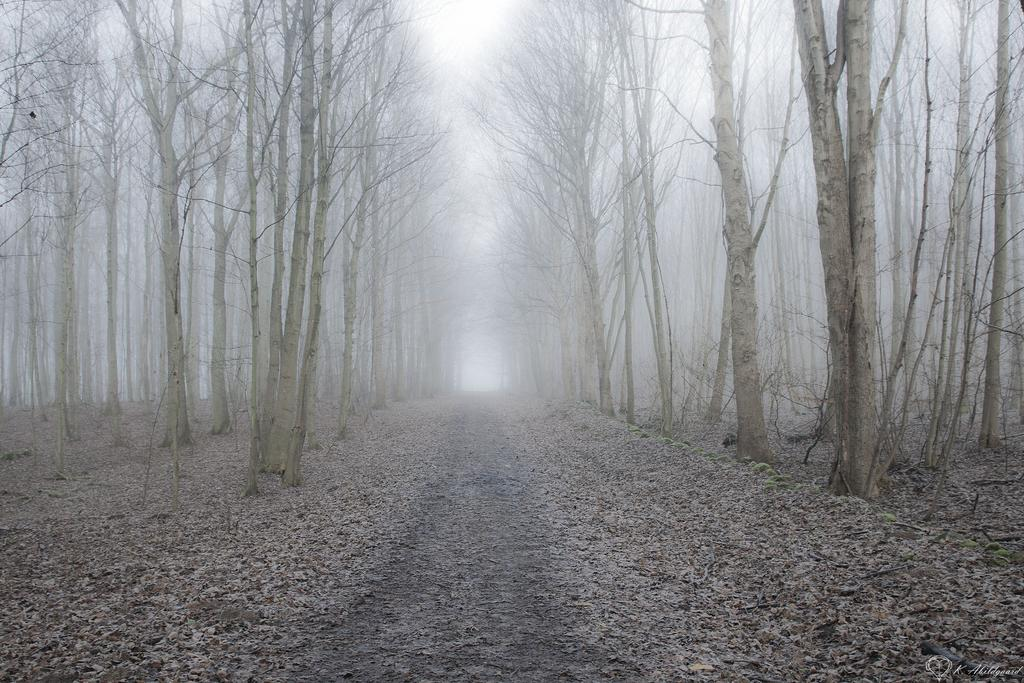What is on the ground in the image? There are dried leaves on the ground in the image. What is the condition of the trees in the image? The trees in the image are bare. What can be seen in the background of the image? The sky is visible in the background of the image. How many rabbits are eating honey in the image? There are no rabbits or honey present in the image. What type of creature is shown interacting with the honey in the image? There is no creature shown interacting with honey in the image; only dried leaves, bare trees, and the sky are present. 